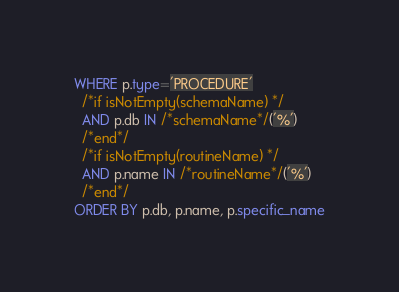<code> <loc_0><loc_0><loc_500><loc_500><_SQL_>WHERE p.type='PROCEDURE'
  /*if isNotEmpty(schemaName) */
  AND p.db IN /*schemaName*/('%')
  /*end*/
  /*if isNotEmpty(routineName) */
  AND p.name IN /*routineName*/('%')
  /*end*/
ORDER BY p.db, p.name, p.specific_name</code> 